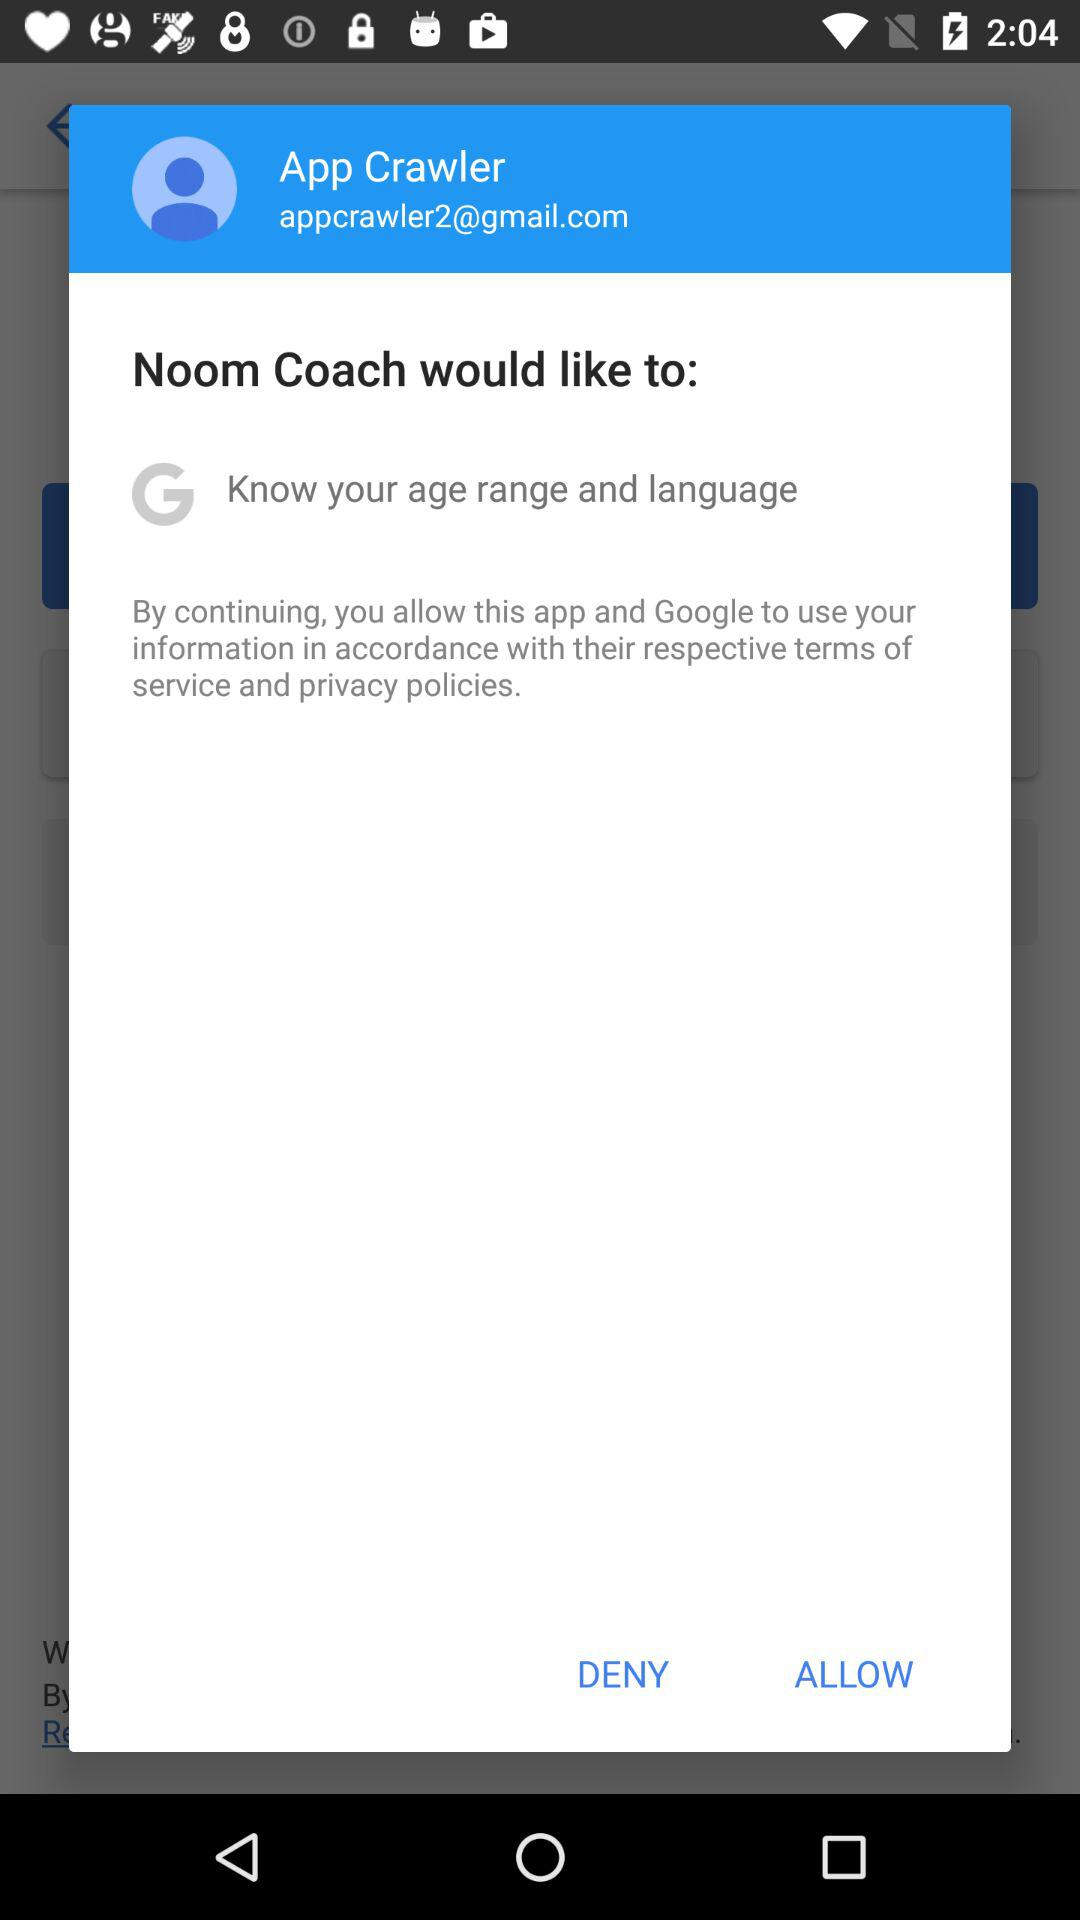What is the email address? The email address is appcrawler2@gmail.com. 